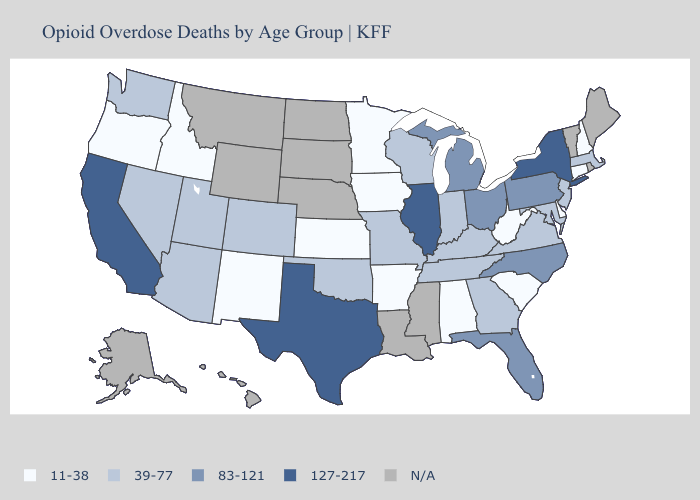What is the value of Tennessee?
Give a very brief answer. 39-77. Name the states that have a value in the range 83-121?
Give a very brief answer. Florida, Michigan, North Carolina, Ohio, Pennsylvania. Does Arkansas have the lowest value in the USA?
Write a very short answer. Yes. What is the value of Montana?
Be succinct. N/A. What is the highest value in the USA?
Give a very brief answer. 127-217. Which states have the lowest value in the MidWest?
Concise answer only. Iowa, Kansas, Minnesota. What is the highest value in states that border Wyoming?
Concise answer only. 39-77. What is the lowest value in states that border California?
Keep it brief. 11-38. Does New York have the highest value in the USA?
Give a very brief answer. Yes. What is the value of Arizona?
Short answer required. 39-77. What is the highest value in the USA?
Give a very brief answer. 127-217. Does Nevada have the lowest value in the West?
Quick response, please. No. How many symbols are there in the legend?
Keep it brief. 5. Name the states that have a value in the range 127-217?
Be succinct. California, Illinois, New York, Texas. Which states hav the highest value in the South?
Write a very short answer. Texas. 